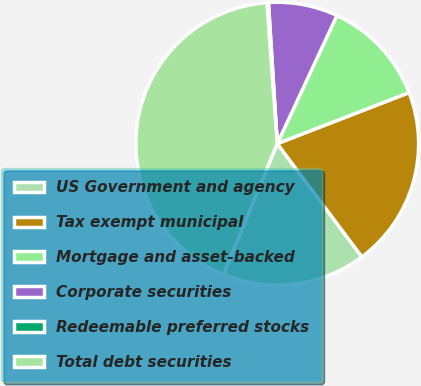Convert chart. <chart><loc_0><loc_0><loc_500><loc_500><pie_chart><fcel>US Government and agency<fcel>Tax exempt municipal<fcel>Mortgage and asset-backed<fcel>Corporate securities<fcel>Redeemable preferred stocks<fcel>Total debt securities<nl><fcel>16.42%<fcel>20.67%<fcel>12.18%<fcel>7.93%<fcel>0.17%<fcel>42.63%<nl></chart> 